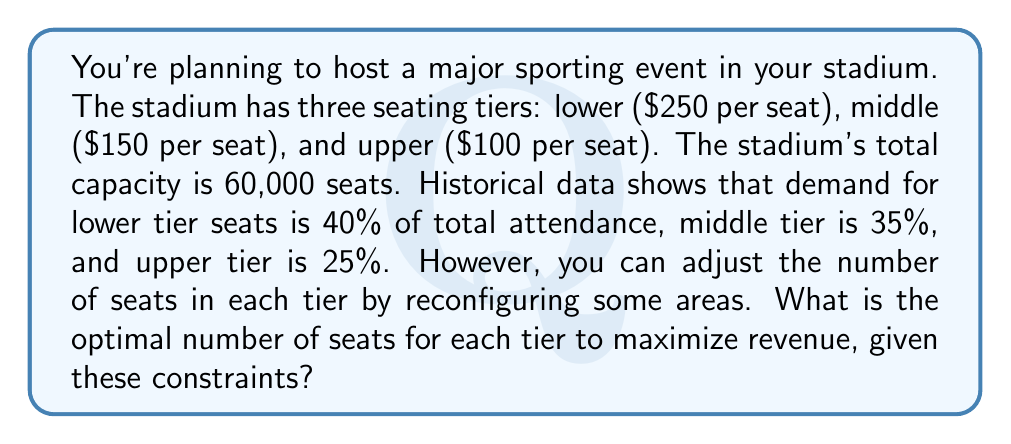Can you answer this question? Let's approach this step-by-step:

1) Let $x$, $y$, and $z$ represent the number of seats in the lower, middle, and upper tiers respectively.

2) Our objective function (revenue) is:
   $$R = 250x + 150y + 100z$$

3) We have the following constraints:
   - Total capacity: $x + y + z = 60,000$
   - Demand ratios: $x : y : z = 40 : 35 : 25 = 8 : 7 : 5$

4) To satisfy the demand ratio, we can express $y$ and $z$ in terms of $x$:
   $$y = \frac{7}{8}x \quad \text{and} \quad z = \frac{5}{8}x$$

5) Substituting these into the total capacity constraint:
   $$x + \frac{7}{8}x + \frac{5}{8}x = 60,000$$
   $$\frac{20}{8}x = 60,000$$
   $$x = 24,000$$

6) Now we can calculate $y$ and $z$:
   $$y = \frac{7}{8}(24,000) = 21,000$$
   $$z = \frac{5}{8}(24,000) = 15,000$$

7) To verify, let's check if these satisfy our constraints:
   - Total capacity: $24,000 + 21,000 + 15,000 = 60,000$ ✓
   - Demand ratios: $24,000 : 21,000 : 15,000 = 8 : 7 : 5$ ✓

8) The maximum revenue is:
   $$R = 250(24,000) + 150(21,000) + 100(15,000) = 10,350,000$$
Answer: Lower tier: 24,000 seats; Middle tier: 21,000 seats; Upper tier: 15,000 seats 